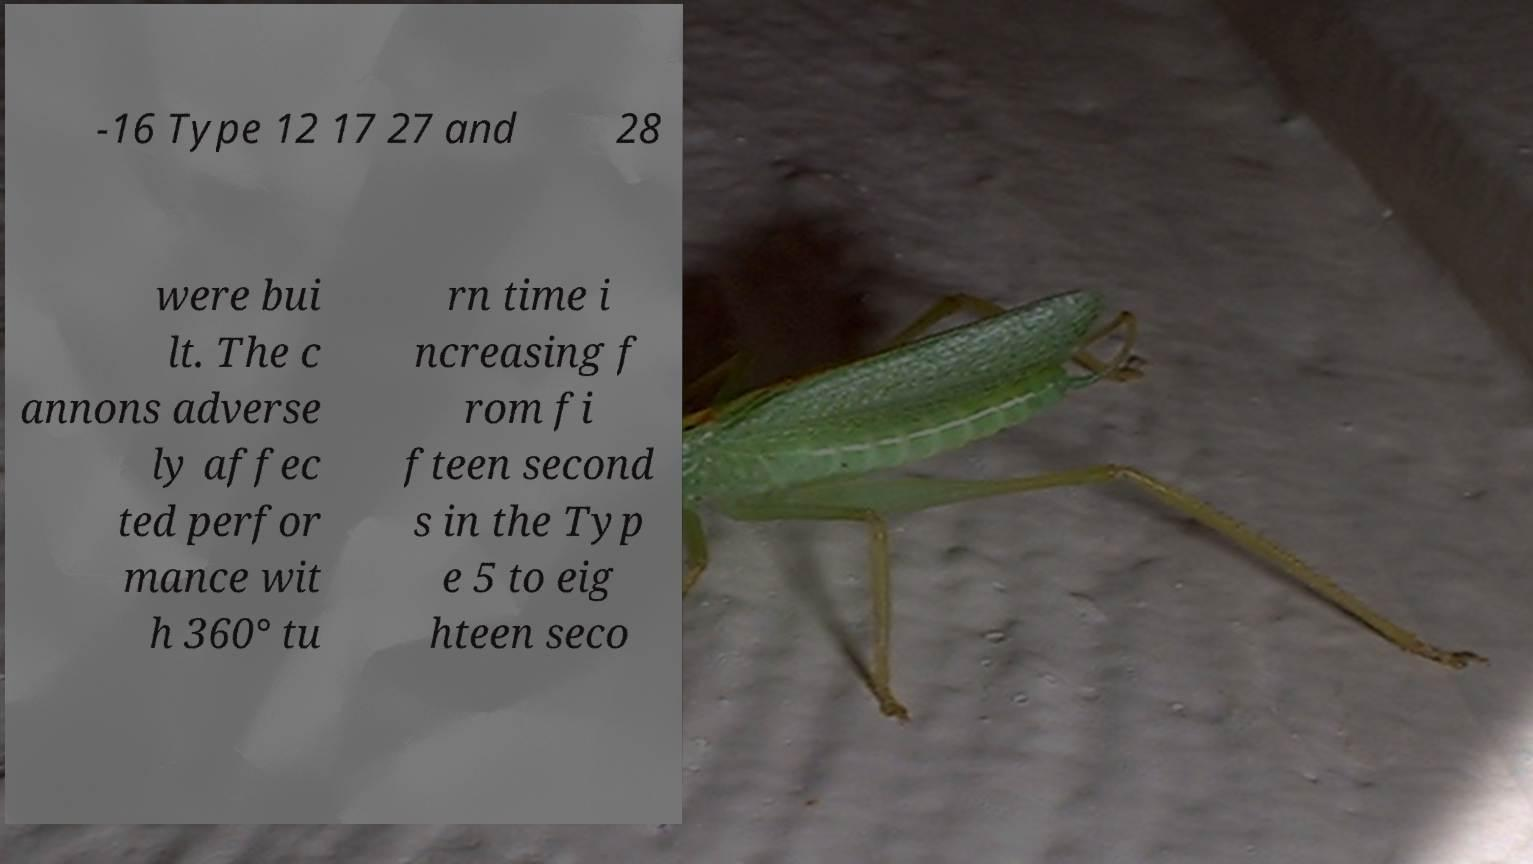Can you accurately transcribe the text from the provided image for me? -16 Type 12 17 27 and 28 were bui lt. The c annons adverse ly affec ted perfor mance wit h 360° tu rn time i ncreasing f rom fi fteen second s in the Typ e 5 to eig hteen seco 